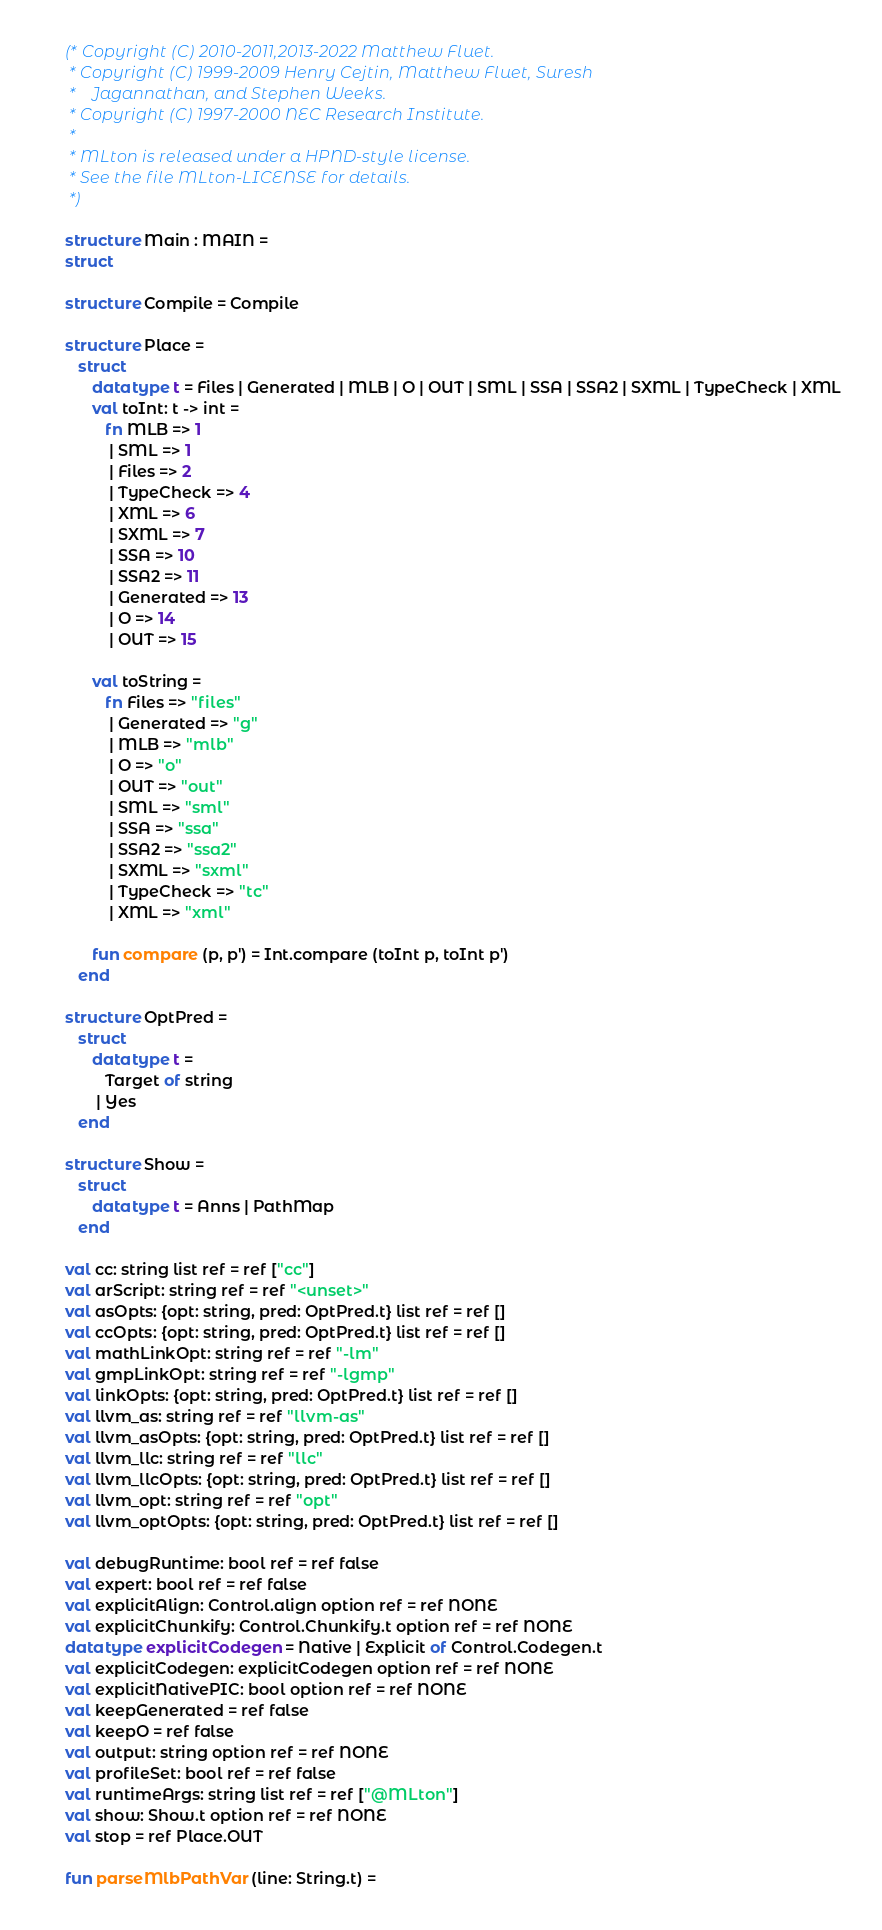<code> <loc_0><loc_0><loc_500><loc_500><_SML_>(* Copyright (C) 2010-2011,2013-2022 Matthew Fluet.
 * Copyright (C) 1999-2009 Henry Cejtin, Matthew Fluet, Suresh
 *    Jagannathan, and Stephen Weeks.
 * Copyright (C) 1997-2000 NEC Research Institute.
 *
 * MLton is released under a HPND-style license.
 * See the file MLton-LICENSE for details.
 *)

structure Main : MAIN =
struct

structure Compile = Compile

structure Place =
   struct
      datatype t = Files | Generated | MLB | O | OUT | SML | SSA | SSA2 | SXML | TypeCheck | XML
      val toInt: t -> int =
         fn MLB => 1
          | SML => 1
          | Files => 2
          | TypeCheck => 4
          | XML => 6
          | SXML => 7
          | SSA => 10
          | SSA2 => 11
          | Generated => 13
          | O => 14
          | OUT => 15

      val toString =
         fn Files => "files"
          | Generated => "g"
          | MLB => "mlb"
          | O => "o"
          | OUT => "out"
          | SML => "sml"
          | SSA => "ssa"
          | SSA2 => "ssa2"
          | SXML => "sxml"
          | TypeCheck => "tc"
          | XML => "xml"

      fun compare (p, p') = Int.compare (toInt p, toInt p')
   end

structure OptPred =
   struct
      datatype t =
         Target of string
       | Yes
   end

structure Show =
   struct
      datatype t = Anns | PathMap
   end

val cc: string list ref = ref ["cc"]
val arScript: string ref = ref "<unset>"
val asOpts: {opt: string, pred: OptPred.t} list ref = ref []
val ccOpts: {opt: string, pred: OptPred.t} list ref = ref []
val mathLinkOpt: string ref = ref "-lm"
val gmpLinkOpt: string ref = ref "-lgmp"
val linkOpts: {opt: string, pred: OptPred.t} list ref = ref []
val llvm_as: string ref = ref "llvm-as"
val llvm_asOpts: {opt: string, pred: OptPred.t} list ref = ref []
val llvm_llc: string ref = ref "llc"
val llvm_llcOpts: {opt: string, pred: OptPred.t} list ref = ref []
val llvm_opt: string ref = ref "opt"
val llvm_optOpts: {opt: string, pred: OptPred.t} list ref = ref []

val debugRuntime: bool ref = ref false
val expert: bool ref = ref false
val explicitAlign: Control.align option ref = ref NONE
val explicitChunkify: Control.Chunkify.t option ref = ref NONE
datatype explicitCodegen = Native | Explicit of Control.Codegen.t
val explicitCodegen: explicitCodegen option ref = ref NONE
val explicitNativePIC: bool option ref = ref NONE
val keepGenerated = ref false
val keepO = ref false
val output: string option ref = ref NONE
val profileSet: bool ref = ref false
val runtimeArgs: string list ref = ref ["@MLton"]
val show: Show.t option ref = ref NONE
val stop = ref Place.OUT

fun parseMlbPathVar (line: String.t) =</code> 